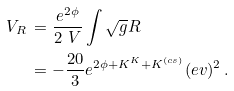Convert formula to latex. <formula><loc_0><loc_0><loc_500><loc_500>V _ { R } \, & = \frac { e ^ { 2 \phi } } { 2 \ V } \int \sqrt { g } R \\ & = - \frac { 2 0 } { 3 } e ^ { 2 \phi + K ^ { K } + K ^ { ( c s ) } } ( e v ) ^ { 2 } \, .</formula> 